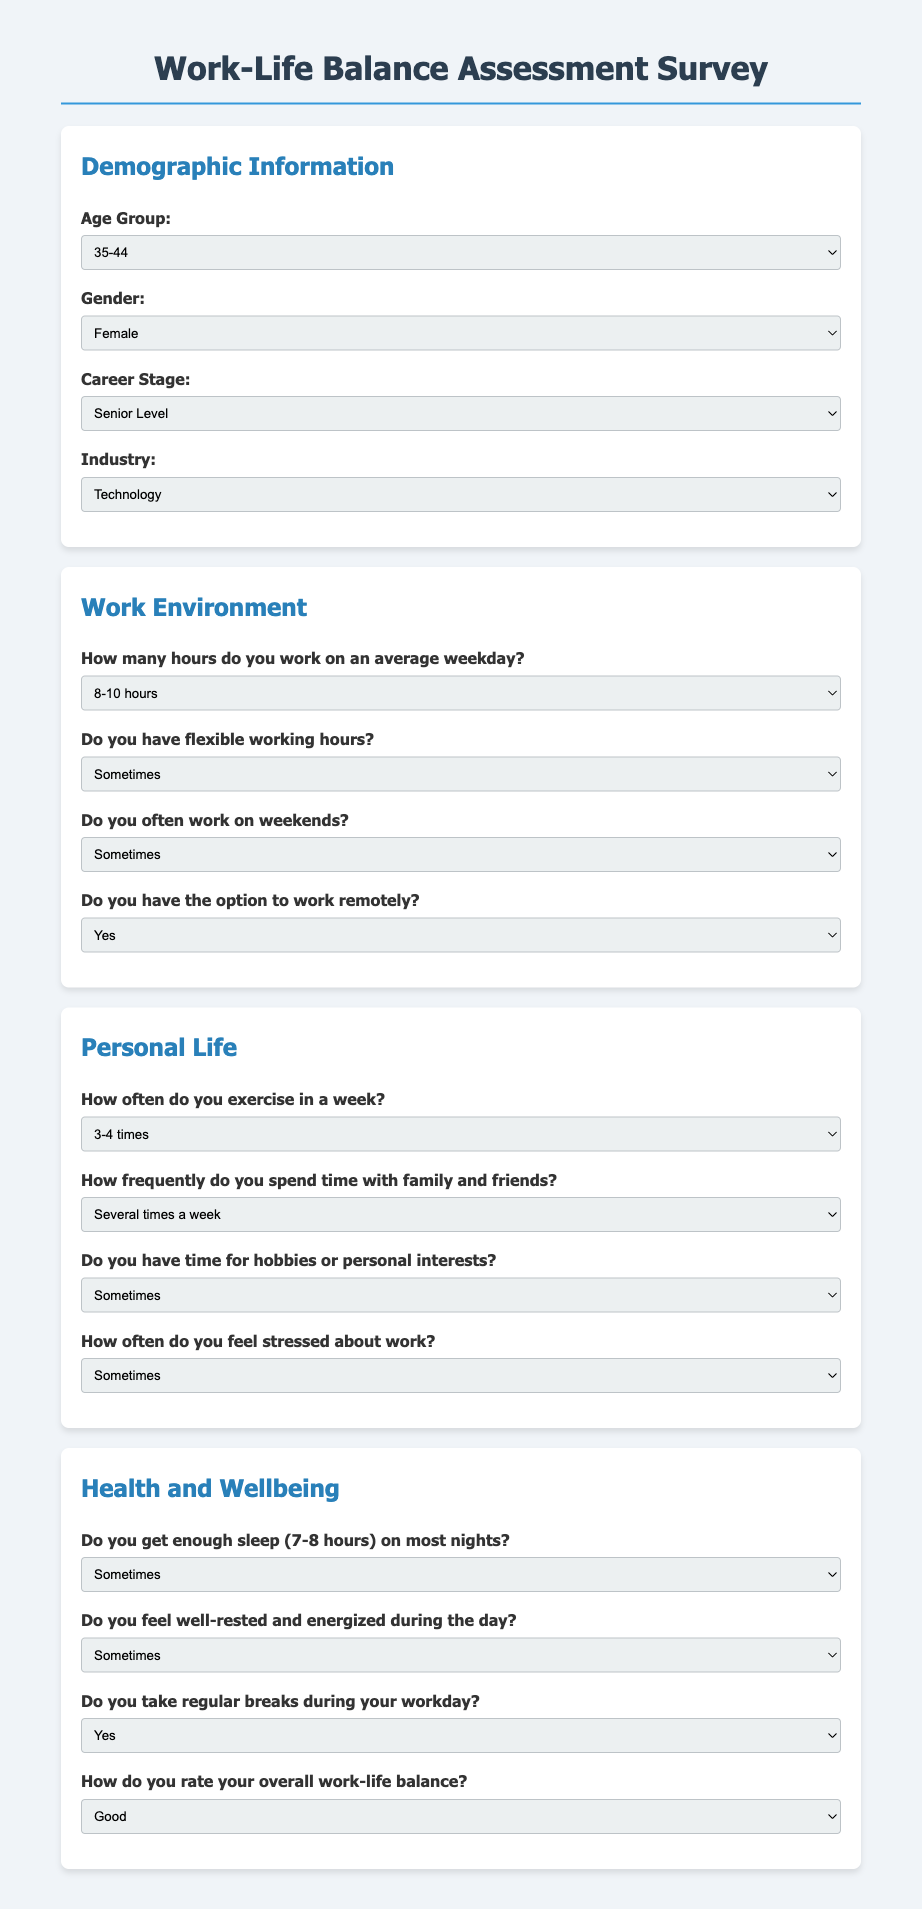What age group is listed as an option? The document provides several age groups to choose from for demographic information. One of the options listed is "35-44".
Answer: 35-44 What is the maximum work hours option in the work environment section? The survey lists multiple options relating to average work hours on weekdays. The maximum is "More than 10 hours".
Answer: More than 10 hours What frequency of exercise is indicated as the highest option in the personal life section? In the personal life section, respondents can indicate how often they exercise. The highest option provided is "5 or more times".
Answer: 5 or more times What are the choices for the question about taking breaks during the workday? The breaks section has three choices that respondents can select from regarding break frequency. They are "Yes", "No", and "Sometimes".
Answer: Yes, No, Sometimes How is overall work-life balance rated in the document? The survey allows respondents to rate their overall work-life balance with several options, one being "Excellent".
Answer: Excellent Do participants have the option to work remotely? The document includes a question about the possibility of working remotely with options. One of the options is "Yes".
Answer: Yes What is the lowest frequency option regarding spending time with family and friends? The survey provides different frequency options for social time. The lowest option listed is "Rarely".
Answer: Rarely How often do respondents feel stressed about work? The document asks about the frequency of work-related stress and provides multiple options. One common option is "Often".
Answer: Often Is there an option to indicate gender in the demographic section? The survey collects demographic information, and one of the attributes it requests is gender, providing several options.
Answer: Yes 